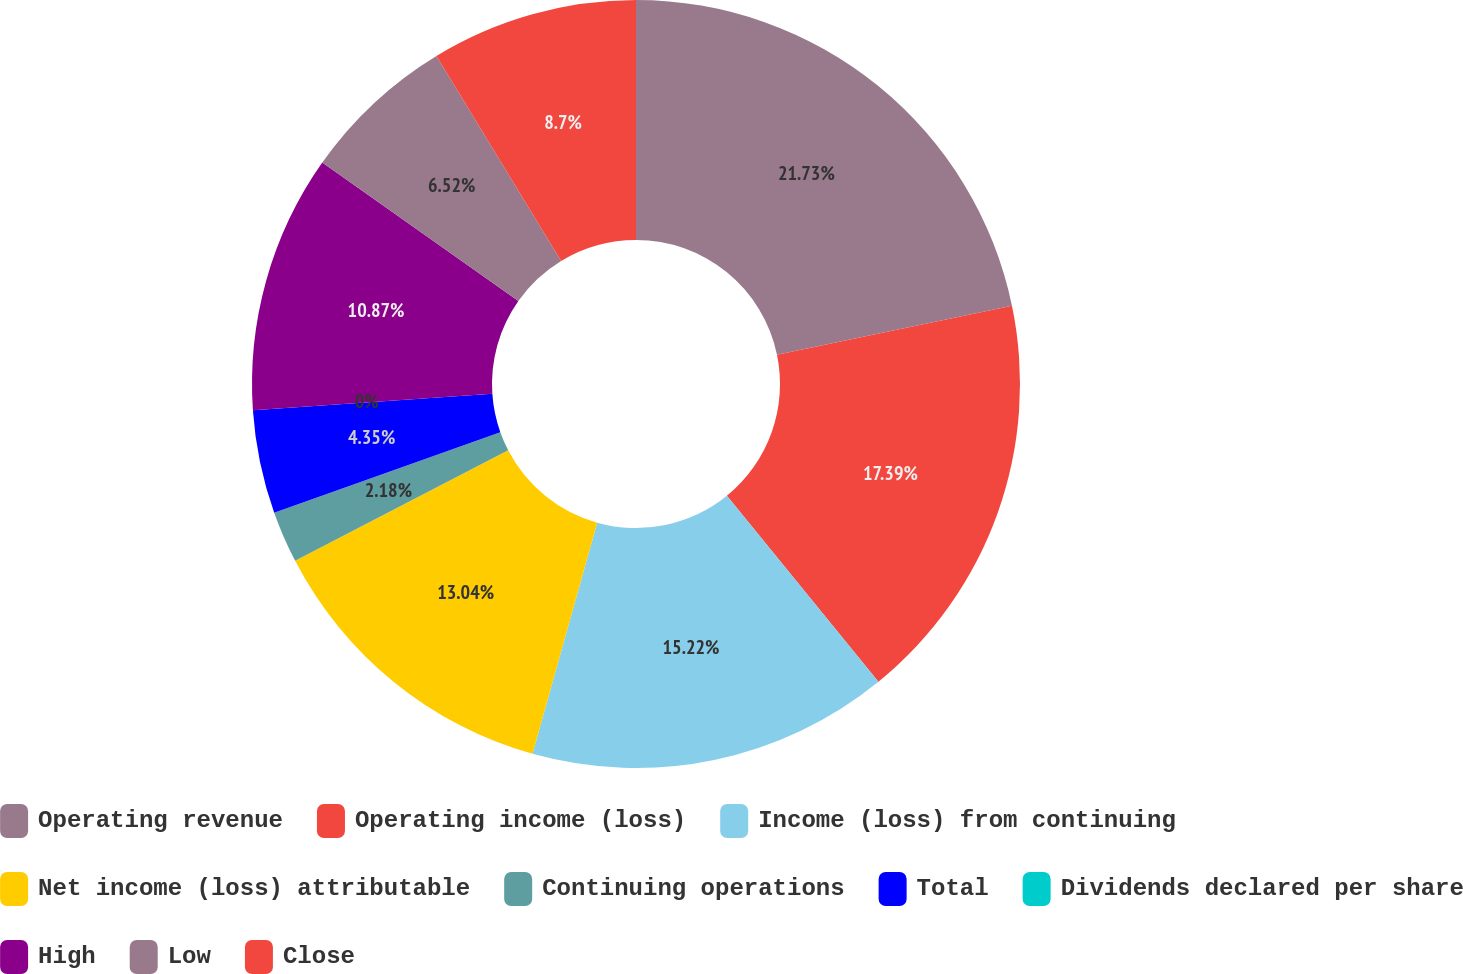<chart> <loc_0><loc_0><loc_500><loc_500><pie_chart><fcel>Operating revenue<fcel>Operating income (loss)<fcel>Income (loss) from continuing<fcel>Net income (loss) attributable<fcel>Continuing operations<fcel>Total<fcel>Dividends declared per share<fcel>High<fcel>Low<fcel>Close<nl><fcel>21.74%<fcel>17.39%<fcel>15.22%<fcel>13.04%<fcel>2.18%<fcel>4.35%<fcel>0.0%<fcel>10.87%<fcel>6.52%<fcel>8.7%<nl></chart> 